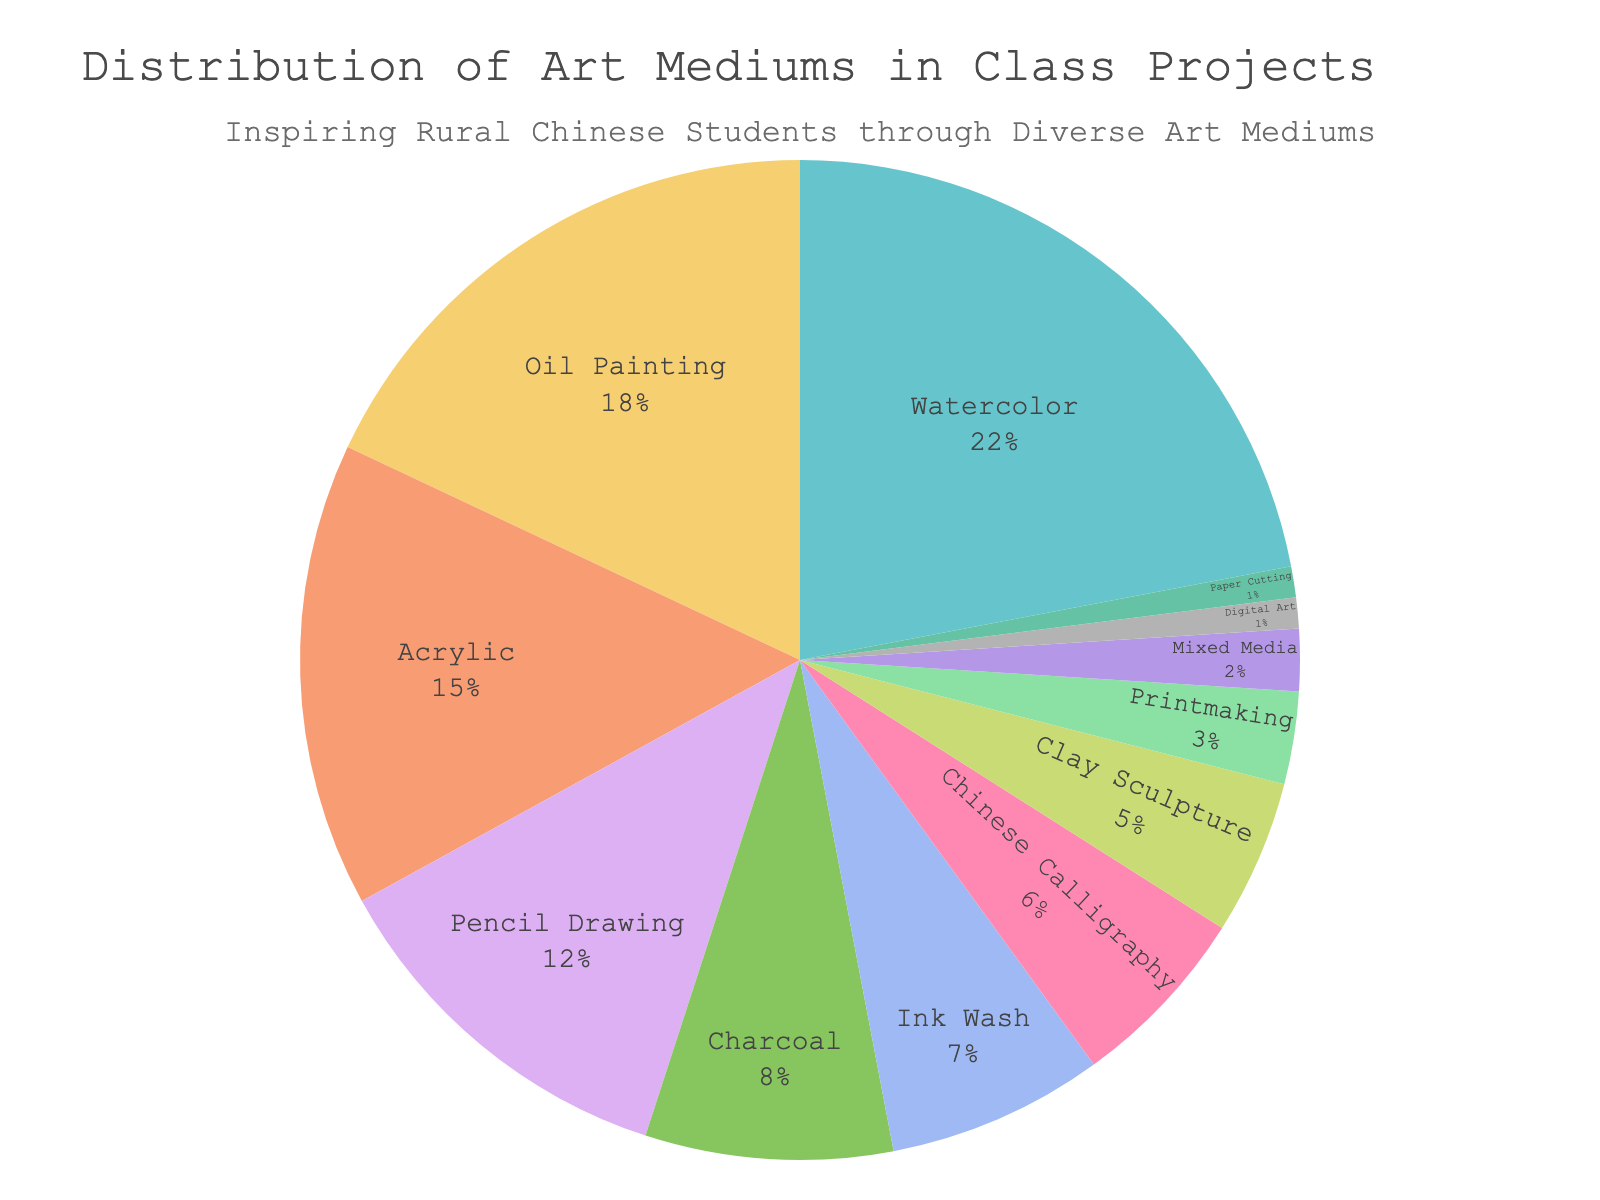What is the most commonly used art medium in class projects? The figure indicates the percentage distribution of each medium, with Watercolor having the highest percentage at 22%.
Answer: Watercolor Which medium is used least by students in their class projects? According to the pie chart, both Digital Art and Paper Cutting have the smallest slices, each representing 1%.
Answer: Digital Art and Paper Cutting What is the total percentage of projects that use traditional Chinese art forms (Chinese Calligraphy and Ink Wash)? Chinese Calligraphy accounts for 6%, and Ink Wash accounts for 7%. Adding these gives 6% + 7% = 13%.
Answer: 13% How much more popular is Watercolor compared to Digital Art? Watercolor has a percentage of 22%, while Digital Art has 1%. The difference is 22% - 1% = 21%.
Answer: 21% If you combine the percentages of Oil Painting, Acrylic, and Clay Sculpture, what is the total? Oil Painting is 18%, Acrylic is 15%, and Clay Sculpture is 5%. The total is 18% + 15% + 5% = 38%.
Answer: 38% What is the difference in popularity between the third most popular medium and the least popular medium? The third most popular medium is Oil Painting at 18%. The least popular mediums (Digital Art and Paper Cutting) are each at 1%. The difference is 18% - 1% = 17%.
Answer: 17% Which medium has a larger share: Pencil Drawing or Charcoal? Pencil Drawing accounts for 12%, while Charcoal accounts for 8%. Therefore, Pencil Drawing has a larger share.
Answer: Pencil Drawing Rank the top three art mediums used in class projects from most to least popular. The top three art mediums based on the percentages are: 1) Watercolor (22%), 2) Oil Painting (18%), and 3) Acrylic (15%).
Answer: Watercolor, Oil Painting, Acrylic What percentage of class projects utilize either Mixed Media or Printmaking? Mixed Media is used in 2% of the projects and Printmaking in 3%. The combined percentage is 2% + 3% = 5%.
Answer: 5% How does the percentage of projects using Ink Wash compare to those using Charcoal? Ink Wash is used in 7% of the projects, and Charcoal in 8%. Ink Wash is 1% less popular than Charcoal.
Answer: 1% less 